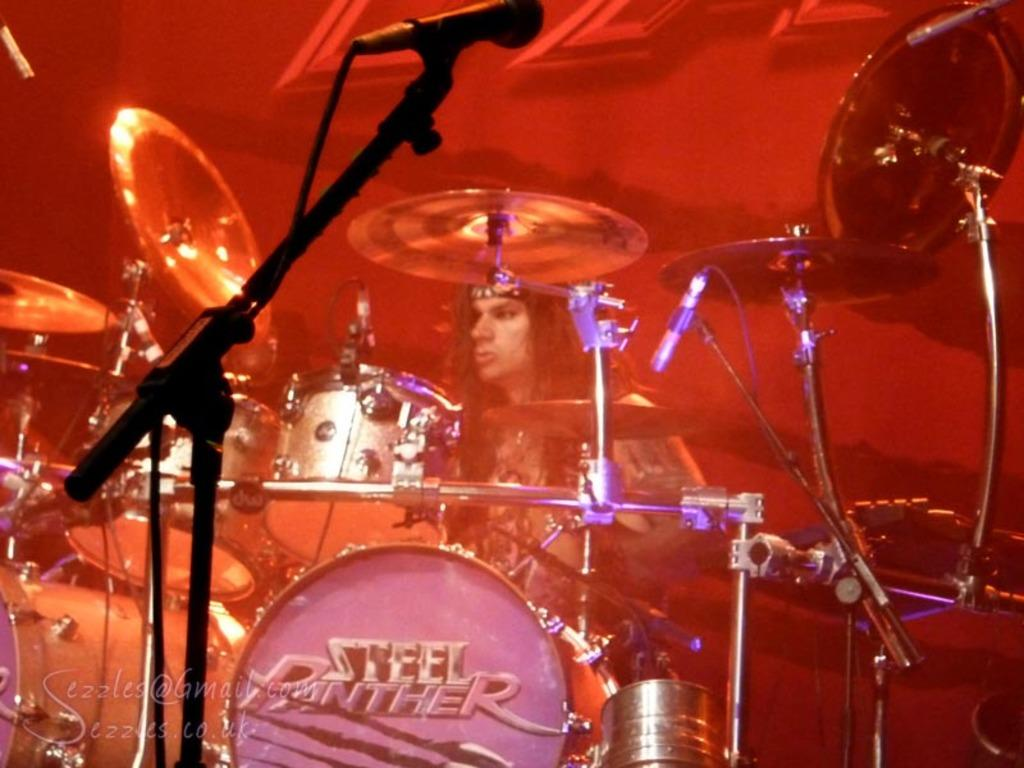What is the main subject of focus of the image? The main focus of the image is a music band. What is the person in the image doing? The person is playing the band, which implies they are a band member or performer. What can be observed about the lighting in the image? Red color light is focusing on the area around the band. What decision does the family make in the image? There is no mention of a family in the image, so it is impossible to determine any decisions they might make. 